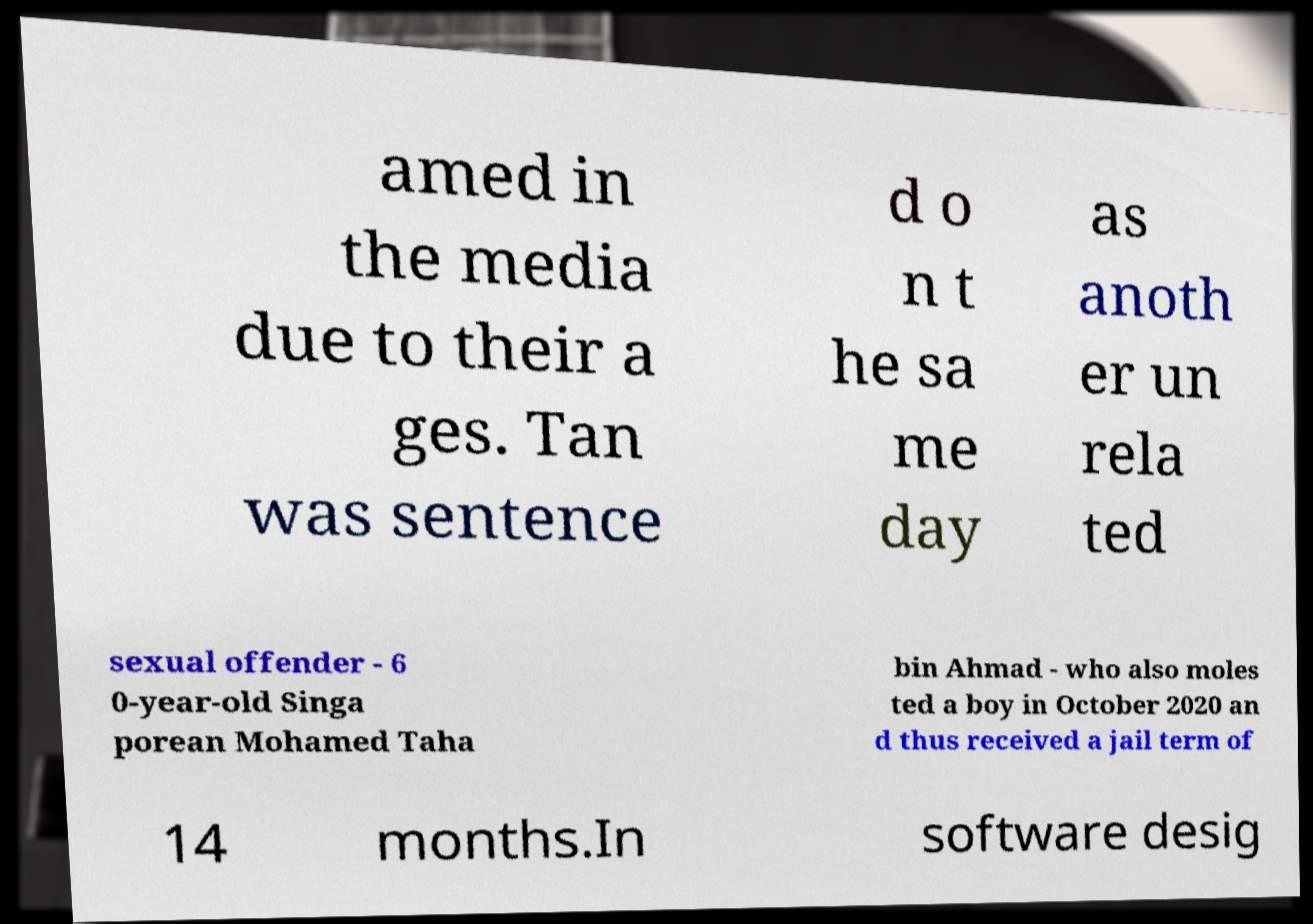For documentation purposes, I need the text within this image transcribed. Could you provide that? amed in the media due to their a ges. Tan was sentence d o n t he sa me day as anoth er un rela ted sexual offender - 6 0-year-old Singa porean Mohamed Taha bin Ahmad - who also moles ted a boy in October 2020 an d thus received a jail term of 14 months.In software desig 